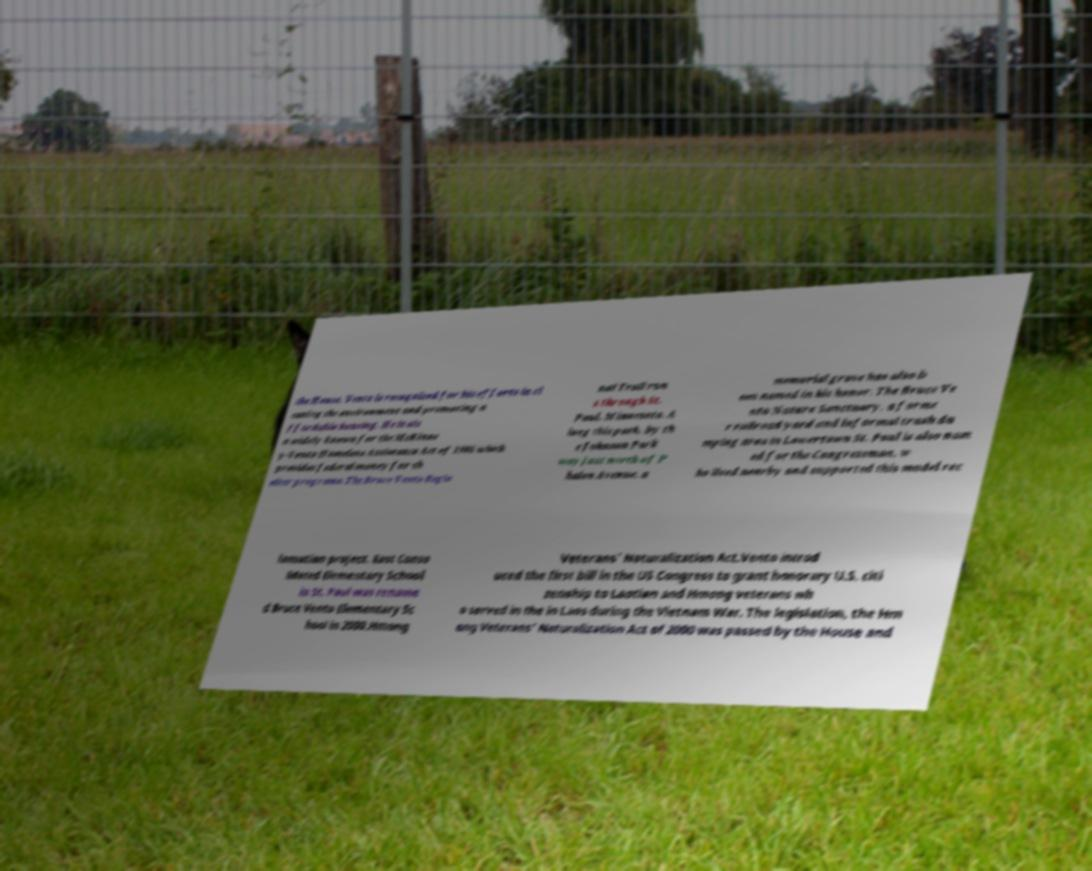I need the written content from this picture converted into text. Can you do that? the House. Vento is recognized for his efforts in cl eaning the environment and promoting a ffordable housing. He is als o widely known for the McKinne y-Vento Homeless Assistance Act of 1986 which provides federal money for sh elter programs.The Bruce Vento Regio nal Trail run s through St. Paul, Minnesota. A long this path, by th e Johnson Park way just north of P halen Avenue, a memorial grove has also b een named in his honor. The Bruce Ve nto Nature Sanctuary, a forme r railroad yard and informal trash du mping area in Lowertown St. Paul is also nam ed for the Congressman, w ho lived nearby and supported this model rec lamation project. East Conso lidated Elementary School in St. Paul was rename d Bruce Vento Elementary Sc hool in 2000.Hmong Veterans' Naturalization Act.Vento introd uced the first bill in the US Congress to grant honorary U.S. citi zenship to Laotian and Hmong veterans wh o served in the in Laos during the Vietnam War. The legislation, the Hm ong Veterans' Naturalization Act of 2000 was passed by the House and 